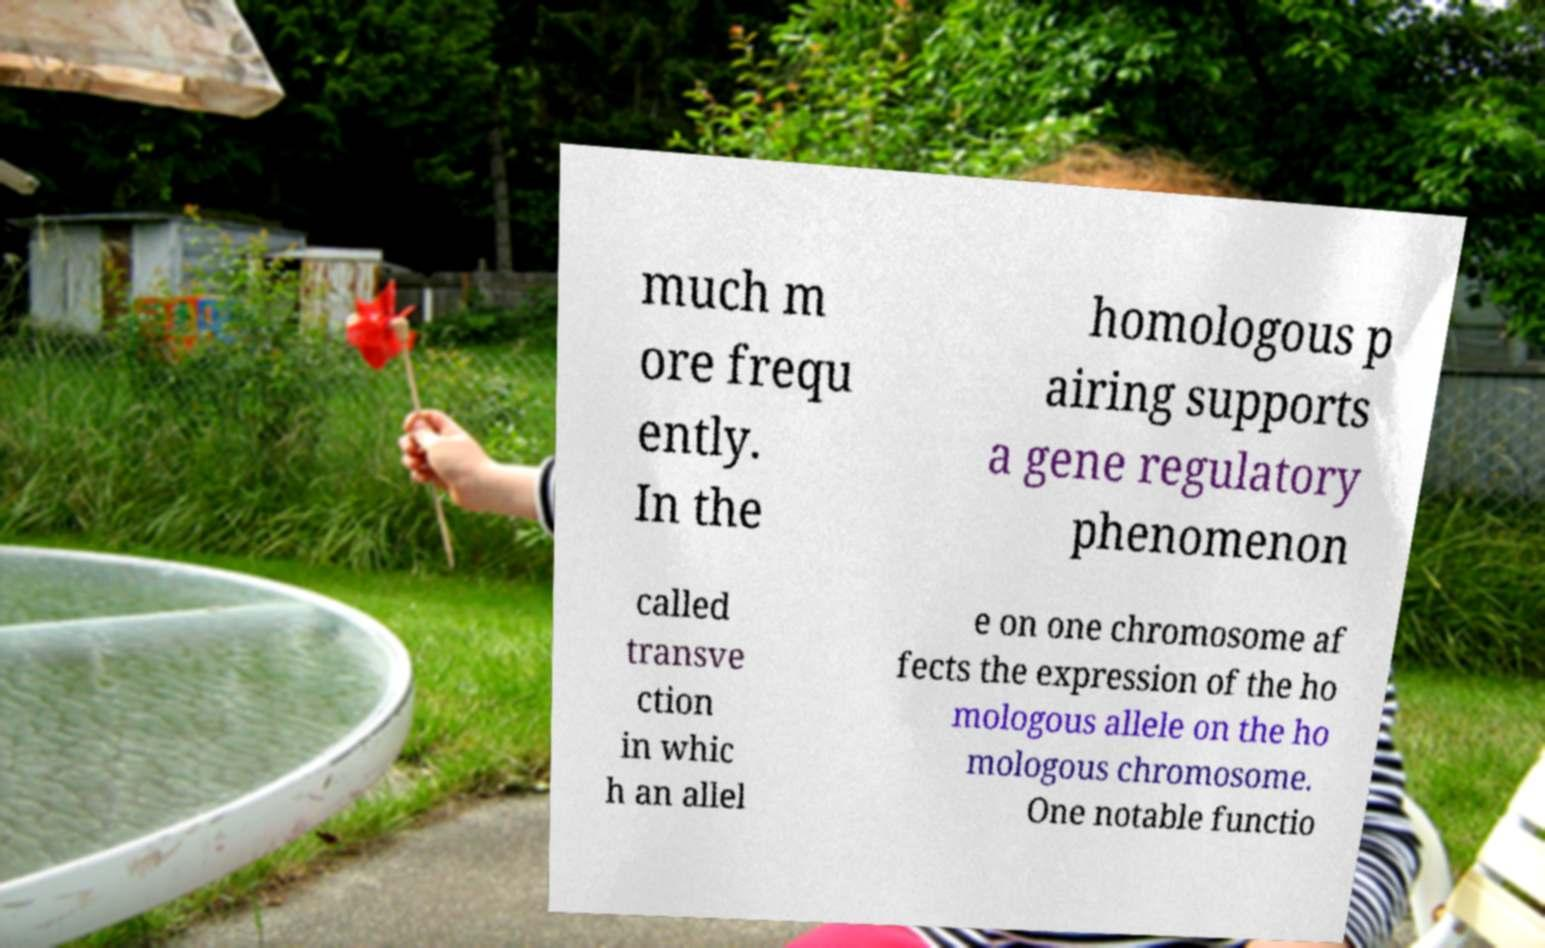There's text embedded in this image that I need extracted. Can you transcribe it verbatim? much m ore frequ ently. In the homologous p airing supports a gene regulatory phenomenon called transve ction in whic h an allel e on one chromosome af fects the expression of the ho mologous allele on the ho mologous chromosome. One notable functio 